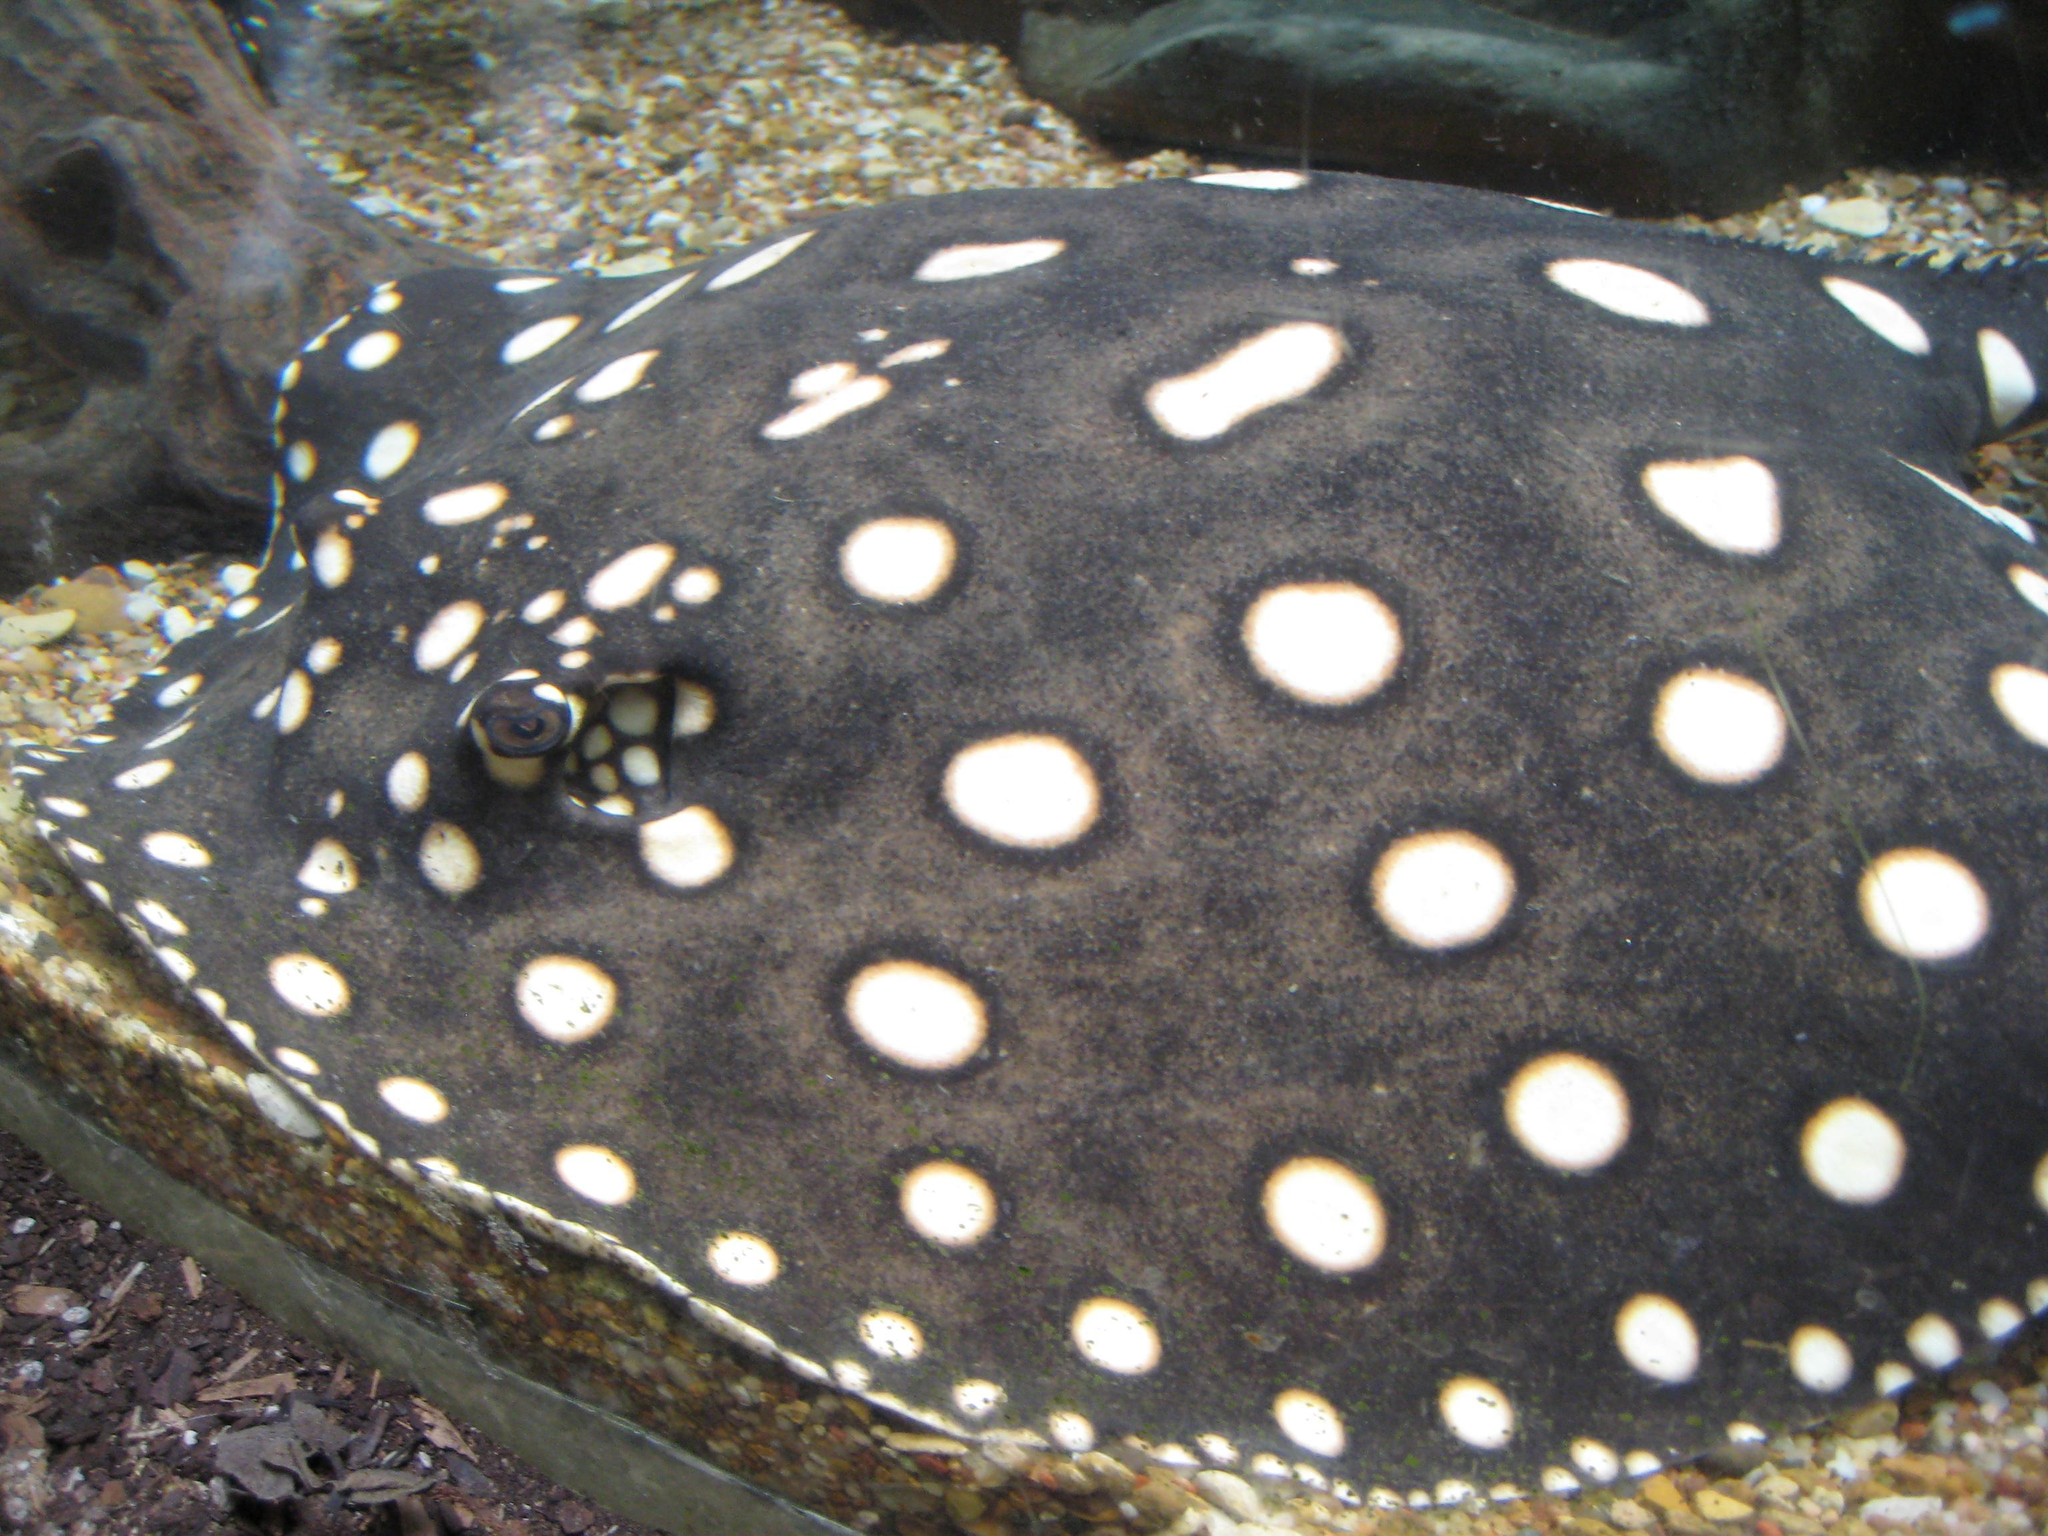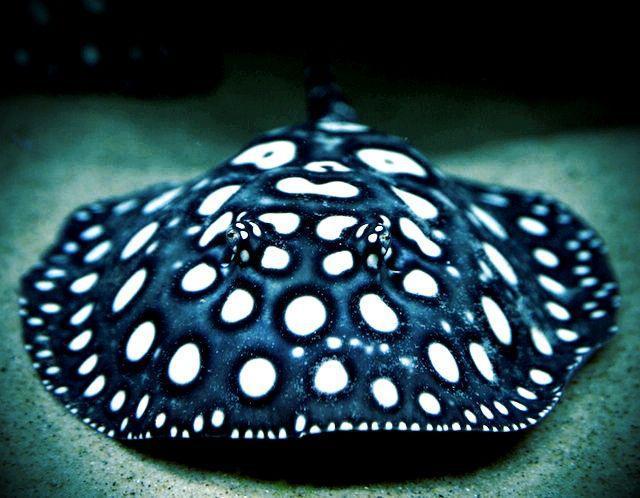The first image is the image on the left, the second image is the image on the right. Given the left and right images, does the statement "There are at least 2 black stingrays with white spots." hold true? Answer yes or no. No. The first image is the image on the left, the second image is the image on the right. Assess this claim about the two images: "There are two stingrays.". Correct or not? Answer yes or no. Yes. 